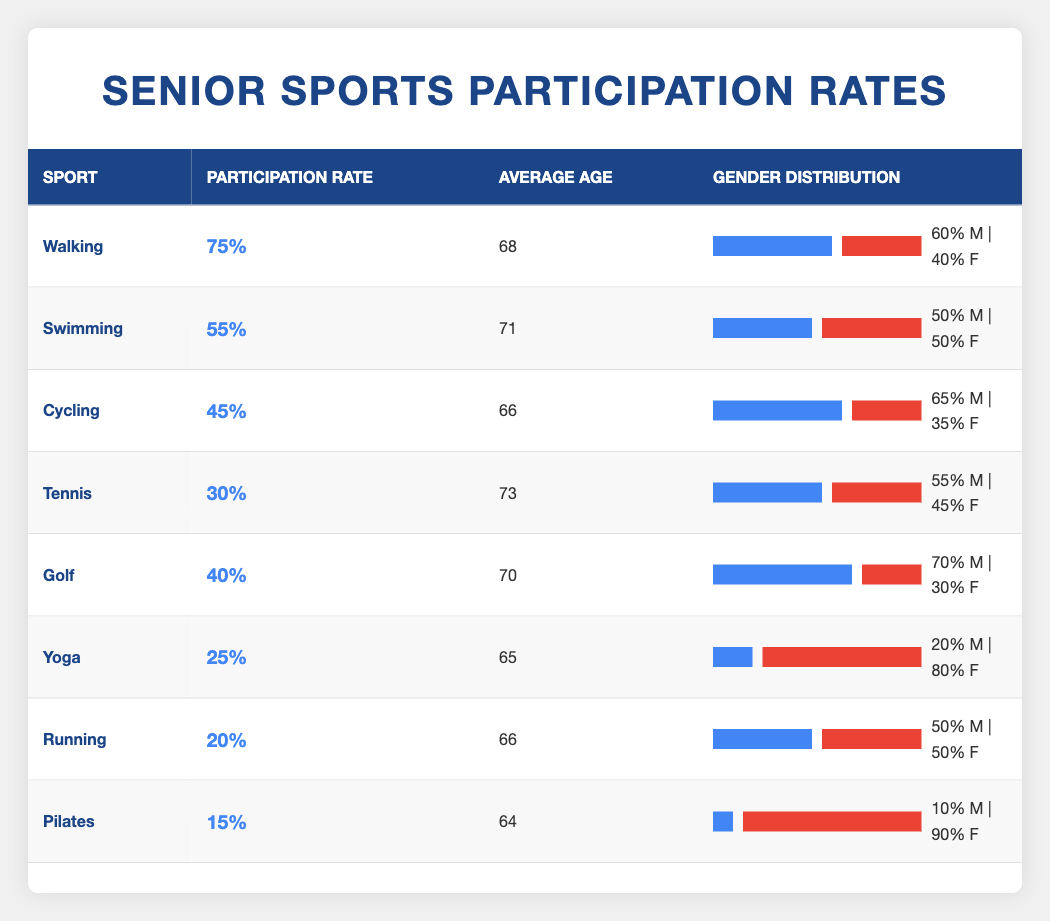What sport has the highest participation rate among seniors? The sports participation rates table lists "Walking" with a participation rate of 75%, which is higher than all other sports.
Answer: Walking What is the average age of participants in Tennis? According to the table, the average age of participants in Tennis is stated as 73 years.
Answer: 73 Which sport has a gender distribution of 80% female participation? The table indicates "Yoga" has a gender distribution where 80% of participants are female.
Answer: Yoga How does the average age of participants in Golf compare to those in Swimming? The average age of Golf participants is 70, while Swimming participants have an average age of 71. Golf is slightly younger by 1 year.
Answer: Golf is younger by 1 year What is the total percentage of male participation across all sports listed? To find the total percentage, sum up the male percentages: 60% (Walking) + 50% (Swimming) + 65% (Cycling) + 55% (Tennis) + 70% (Golf) + 20% (Yoga) + 50% (Running) + 10% (Pilates) = 600%. There are 8 sports, so the average male participation is 600% / 8 = 75%.
Answer: 75% Is it true that Running has a higher participation rate than Tennis? The table indicates Running has a participation rate of 20% and Tennis has a rate of 30%. Thus, Running does not have a higher rate than Tennis.
Answer: No Which sport has the lowest participation rate, and what is the rate? The table shows that "Pilates" has the lowest participation rate at 15%.
Answer: Pilates, 15% What is the difference in participation rates between Walking and Yoga? Walking has a participation rate of 75% and Yoga has a rate of 25%. Subtract Yoga's rate from Walking's: 75% - 25% = 50%.
Answer: 50% Are there more females participating in Yoga than in Cycling? The gender distribution shows Yoga has 80% female participation and Cycling has 35% female participation. Since 80% is greater than 35%, the answer is yes.
Answer: Yes 